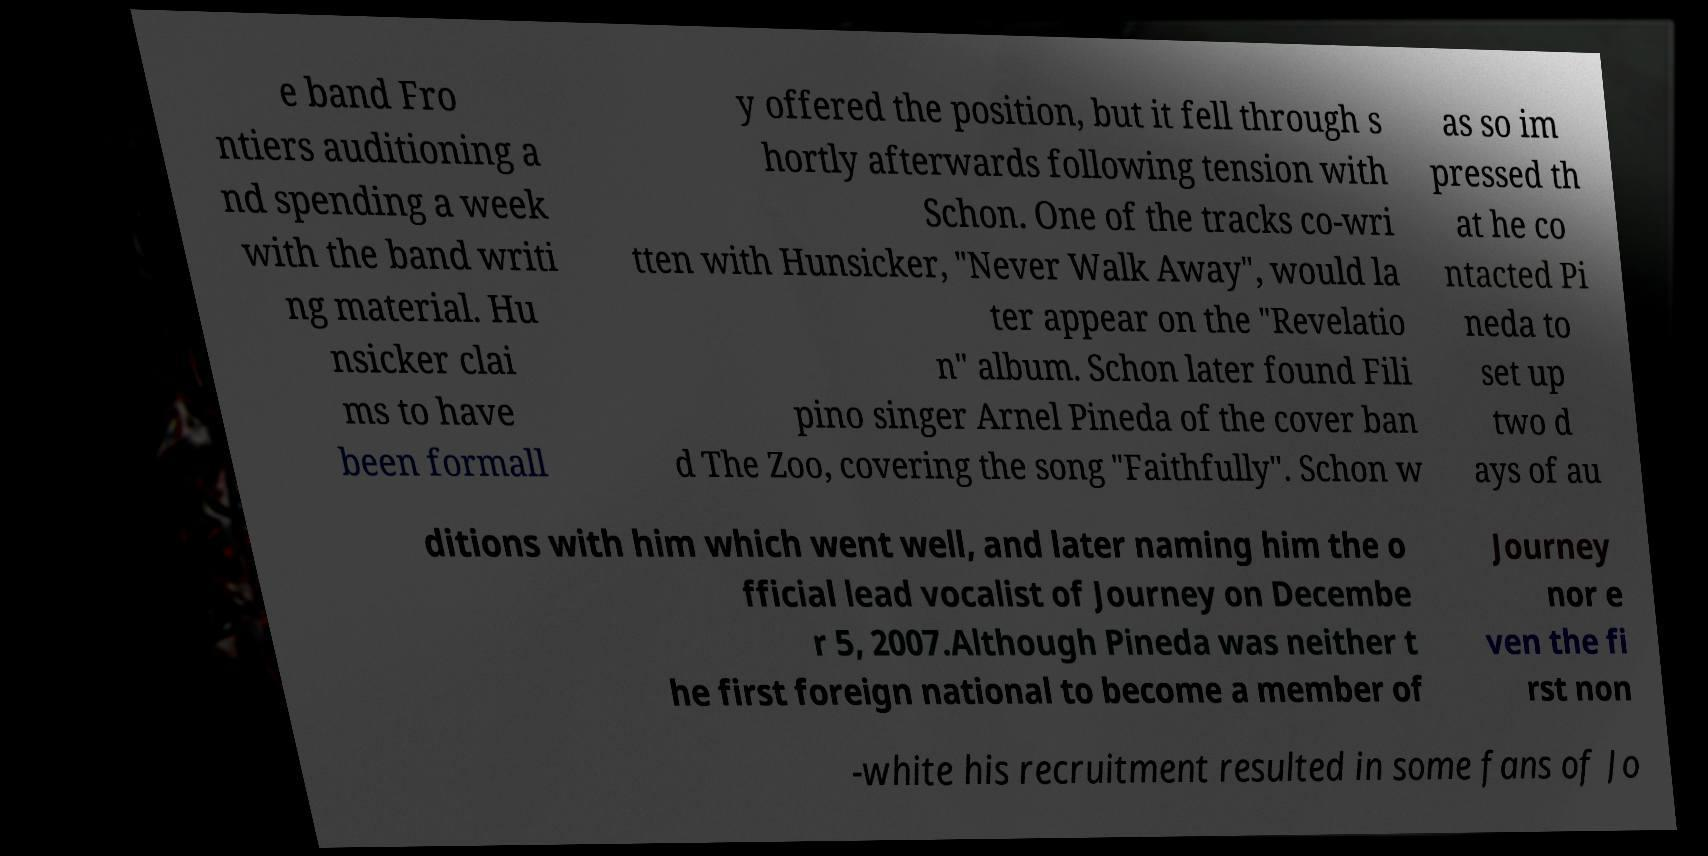I need the written content from this picture converted into text. Can you do that? e band Fro ntiers auditioning a nd spending a week with the band writi ng material. Hu nsicker clai ms to have been formall y offered the position, but it fell through s hortly afterwards following tension with Schon. One of the tracks co-wri tten with Hunsicker, "Never Walk Away", would la ter appear on the "Revelatio n" album. Schon later found Fili pino singer Arnel Pineda of the cover ban d The Zoo, covering the song "Faithfully". Schon w as so im pressed th at he co ntacted Pi neda to set up two d ays of au ditions with him which went well, and later naming him the o fficial lead vocalist of Journey on Decembe r 5, 2007.Although Pineda was neither t he first foreign national to become a member of Journey nor e ven the fi rst non -white his recruitment resulted in some fans of Jo 